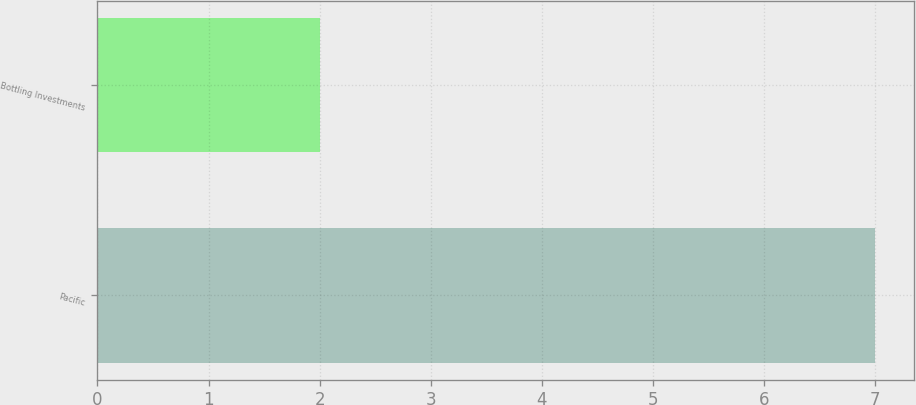<chart> <loc_0><loc_0><loc_500><loc_500><bar_chart><fcel>Pacific<fcel>Bottling Investments<nl><fcel>7<fcel>2<nl></chart> 